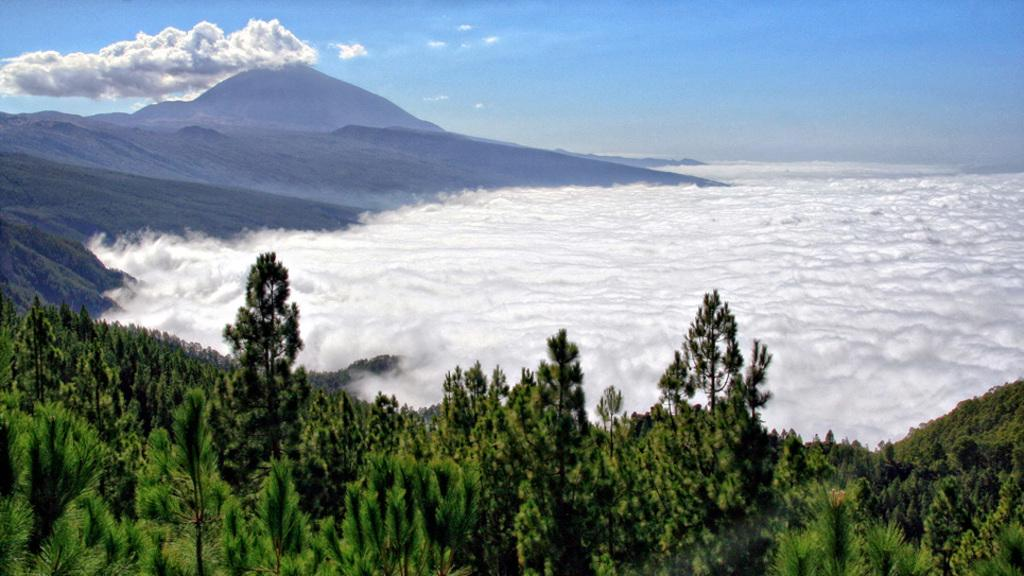What type of vegetation can be seen in the image? There are trees in the image. What can be seen in the sky in the image? There are clouds in the image. What geographical feature is present in the image? There is a mountain in the image. What is visible in the background of the image? The sky is visible in the background of the image. Can you tell me how many goldfish are swimming in the trees in the image? There are no goldfish present in the image; it features trees, clouds, and a mountain. What type of growth can be seen on the mountain in the image? The image does not show any specific growth on the mountain; it only shows the mountain itself. 